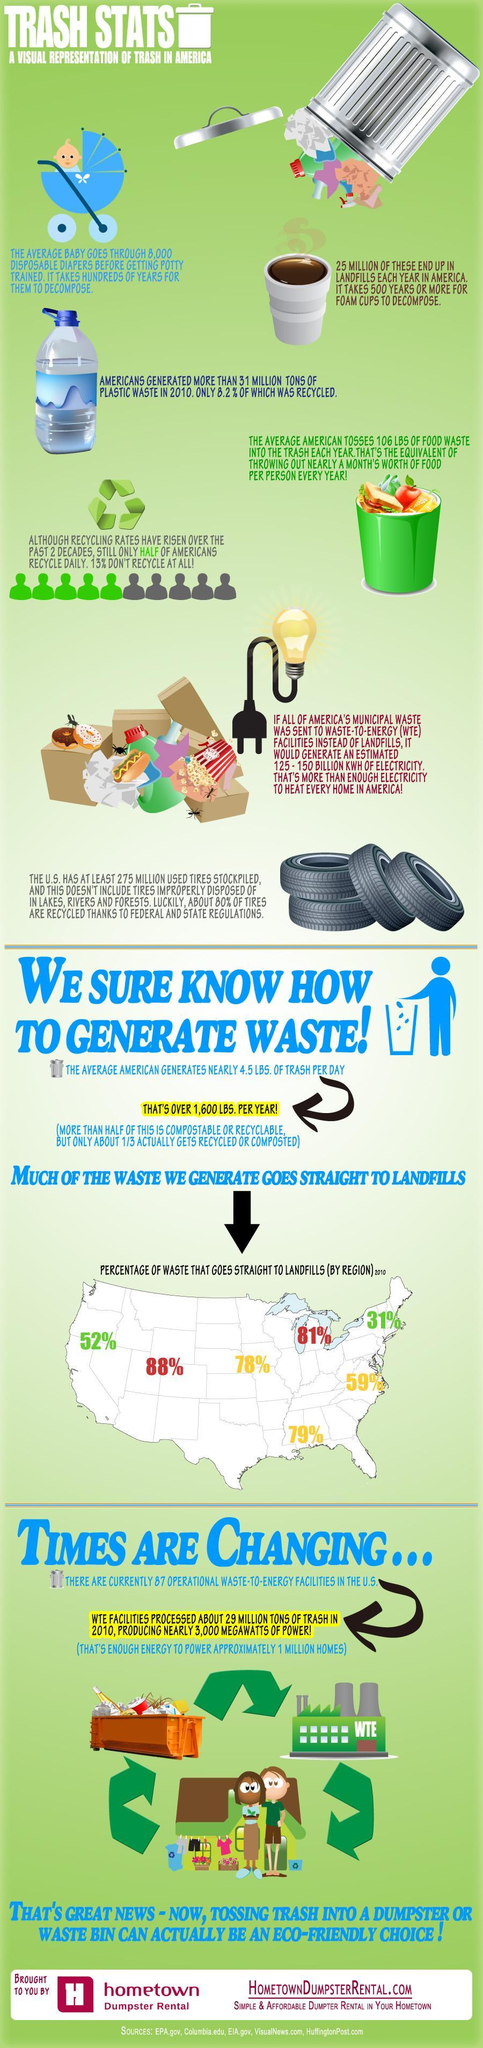How much waste is generated by American in a year?
Answer the question with a short phrase. OVER 1,600 LBS. How many foam cups are genereated as waste every year? 25 MILLION 